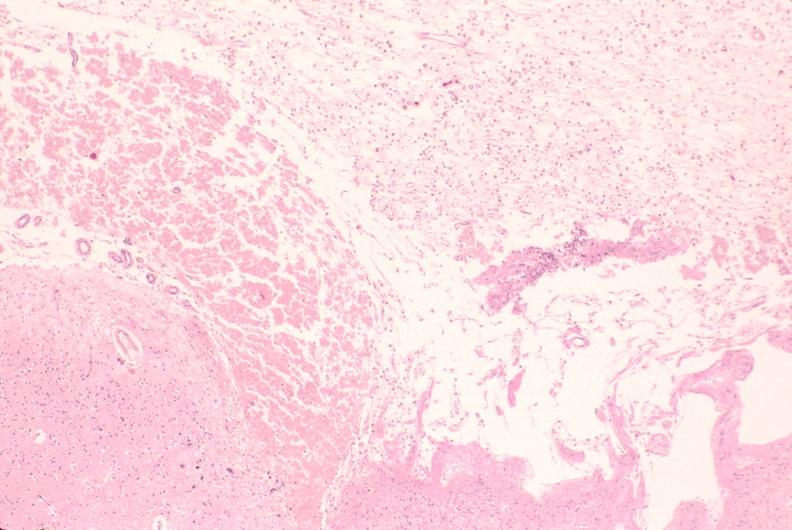s nervous present?
Answer the question using a single word or phrase. Yes 